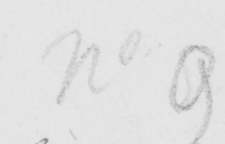Can you read and transcribe this handwriting? No 9 